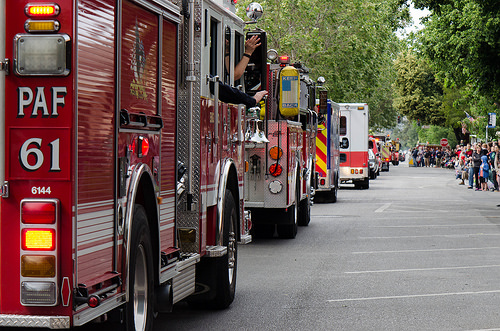<image>
Is the truck to the left of the gas cylinder? No. The truck is not to the left of the gas cylinder. From this viewpoint, they have a different horizontal relationship. 